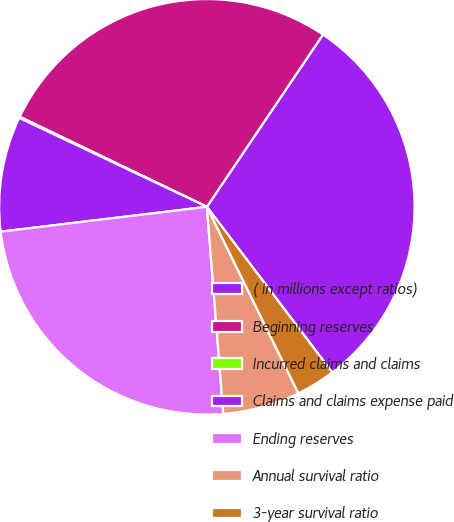Convert chart. <chart><loc_0><loc_0><loc_500><loc_500><pie_chart><fcel>( in millions except ratios)<fcel>Beginning reserves<fcel>Incurred claims and claims<fcel>Claims and claims expense paid<fcel>Ending reserves<fcel>Annual survival ratio<fcel>3-year survival ratio<nl><fcel>30.25%<fcel>27.3%<fcel>0.1%<fcel>8.95%<fcel>24.35%<fcel>6.0%<fcel>3.05%<nl></chart> 